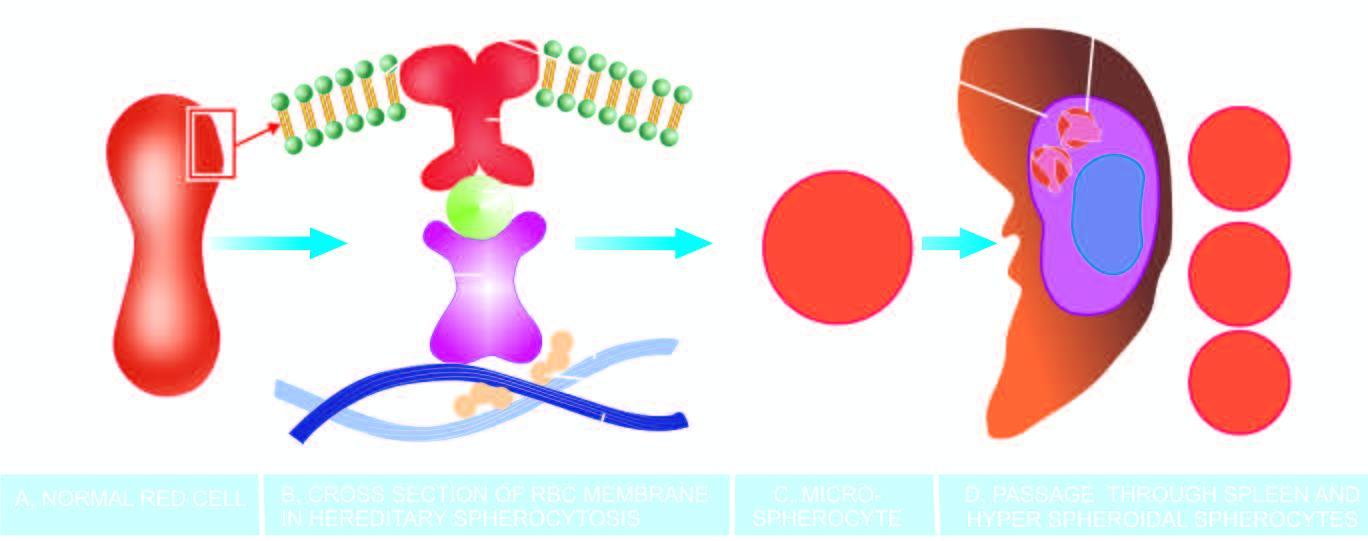d lose whose cell membrane further during passage through the spleen?
Answer the question using a single word or phrase. Their 